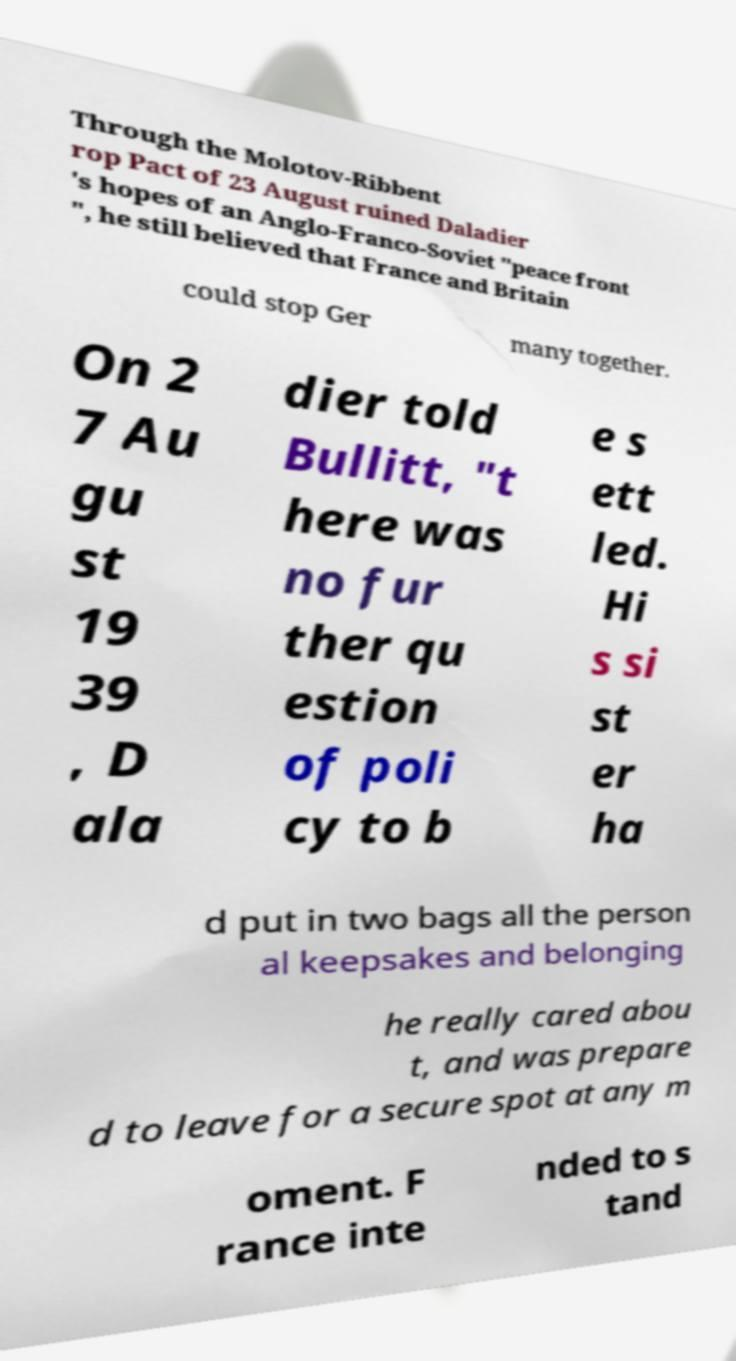There's text embedded in this image that I need extracted. Can you transcribe it verbatim? Through the Molotov-Ribbent rop Pact of 23 August ruined Daladier 's hopes of an Anglo-Franco-Soviet "peace front ", he still believed that France and Britain could stop Ger many together. On 2 7 Au gu st 19 39 , D ala dier told Bullitt, "t here was no fur ther qu estion of poli cy to b e s ett led. Hi s si st er ha d put in two bags all the person al keepsakes and belonging he really cared abou t, and was prepare d to leave for a secure spot at any m oment. F rance inte nded to s tand 